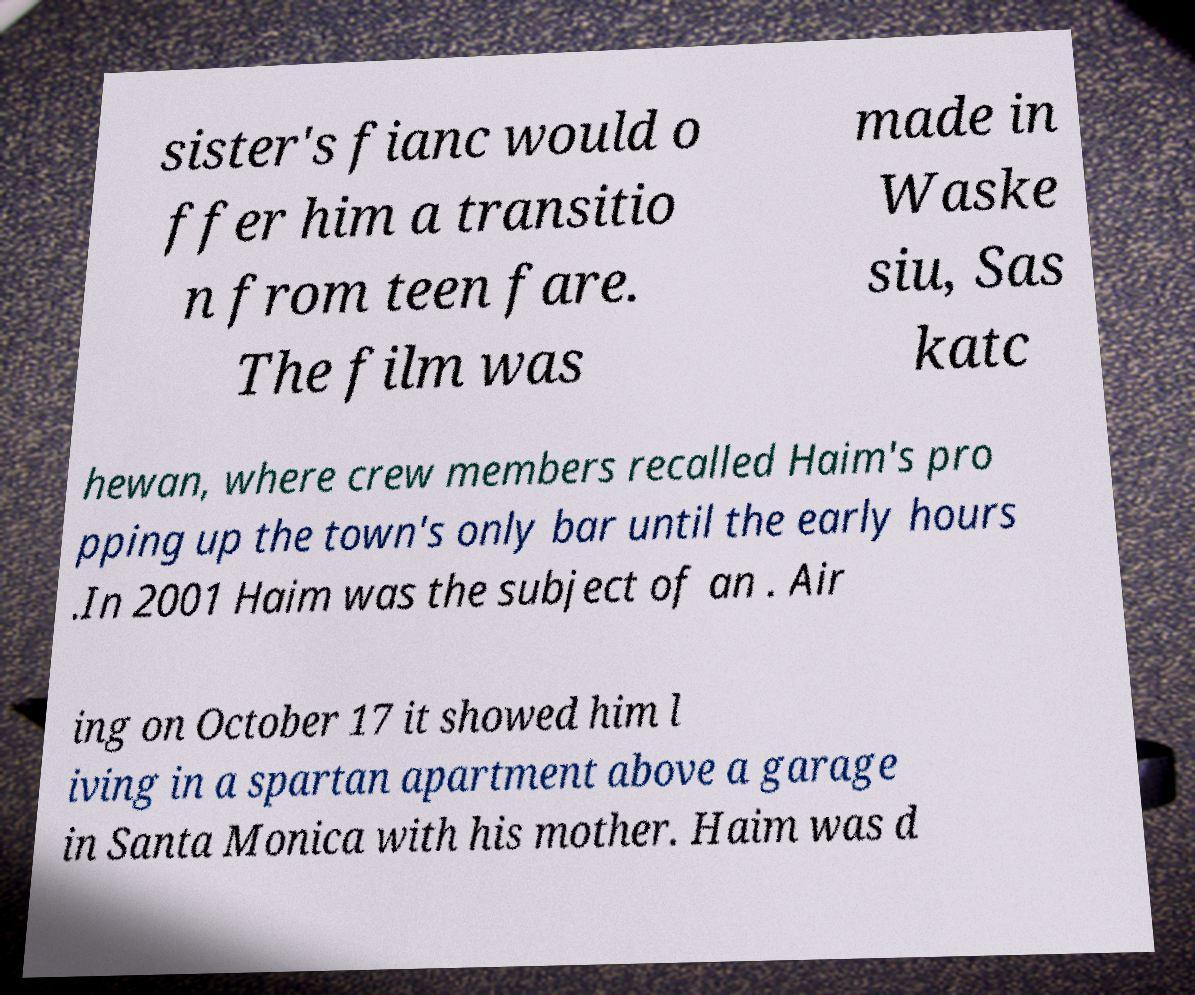For documentation purposes, I need the text within this image transcribed. Could you provide that? sister's fianc would o ffer him a transitio n from teen fare. The film was made in Waske siu, Sas katc hewan, where crew members recalled Haim's pro pping up the town's only bar until the early hours .In 2001 Haim was the subject of an . Air ing on October 17 it showed him l iving in a spartan apartment above a garage in Santa Monica with his mother. Haim was d 